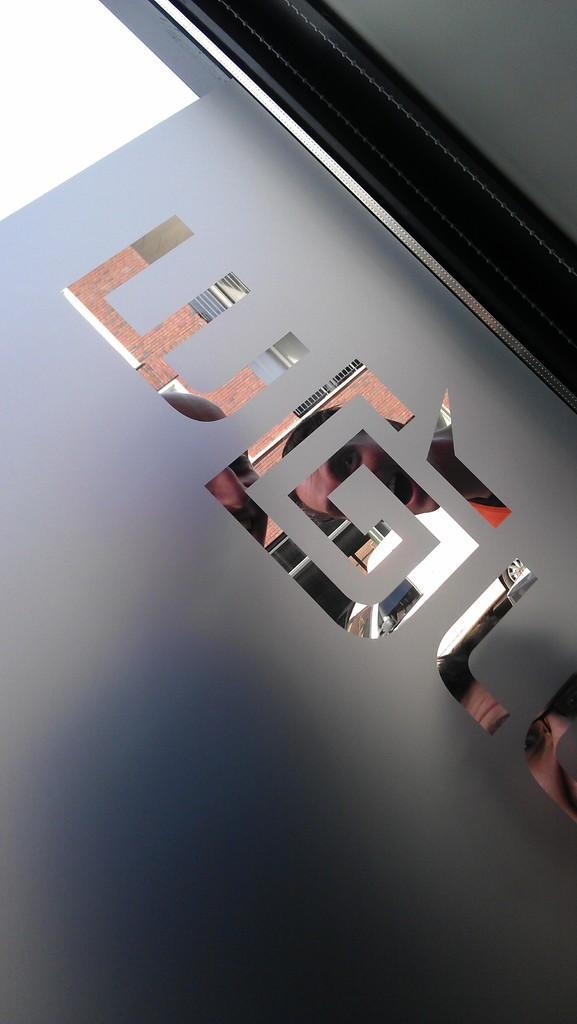What is the color of the main object in the image? The main object in the image is grey. What can be observed on the surface of the grey object? The grey object has designs on it. What is placed on top of the grey object? There is glass on the grey object. Who or what can be seen through the glass? Three persons are visible through the glass. What type of lunch is being served on the floor in the image? There is no lunch or floor present in the image; it features a grey object with glass and three persons visible through the glass. 